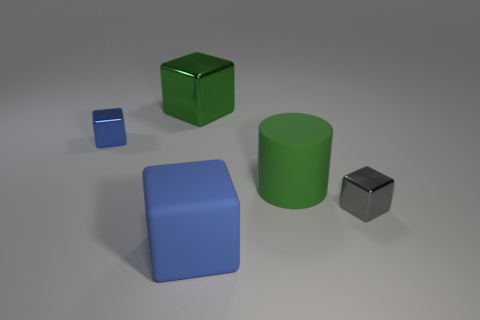Subtract all blue matte blocks. How many blocks are left? 3 Add 5 big objects. How many objects exist? 10 Subtract all green cubes. How many cubes are left? 3 Subtract all cyan cylinders. How many blue blocks are left? 2 Subtract all blocks. How many objects are left? 1 Subtract all purple cylinders. Subtract all green spheres. How many cylinders are left? 1 Subtract all small blue metallic cubes. Subtract all large cyan matte balls. How many objects are left? 4 Add 1 green metal objects. How many green metal objects are left? 2 Add 1 small brown spheres. How many small brown spheres exist? 1 Subtract 0 yellow cubes. How many objects are left? 5 